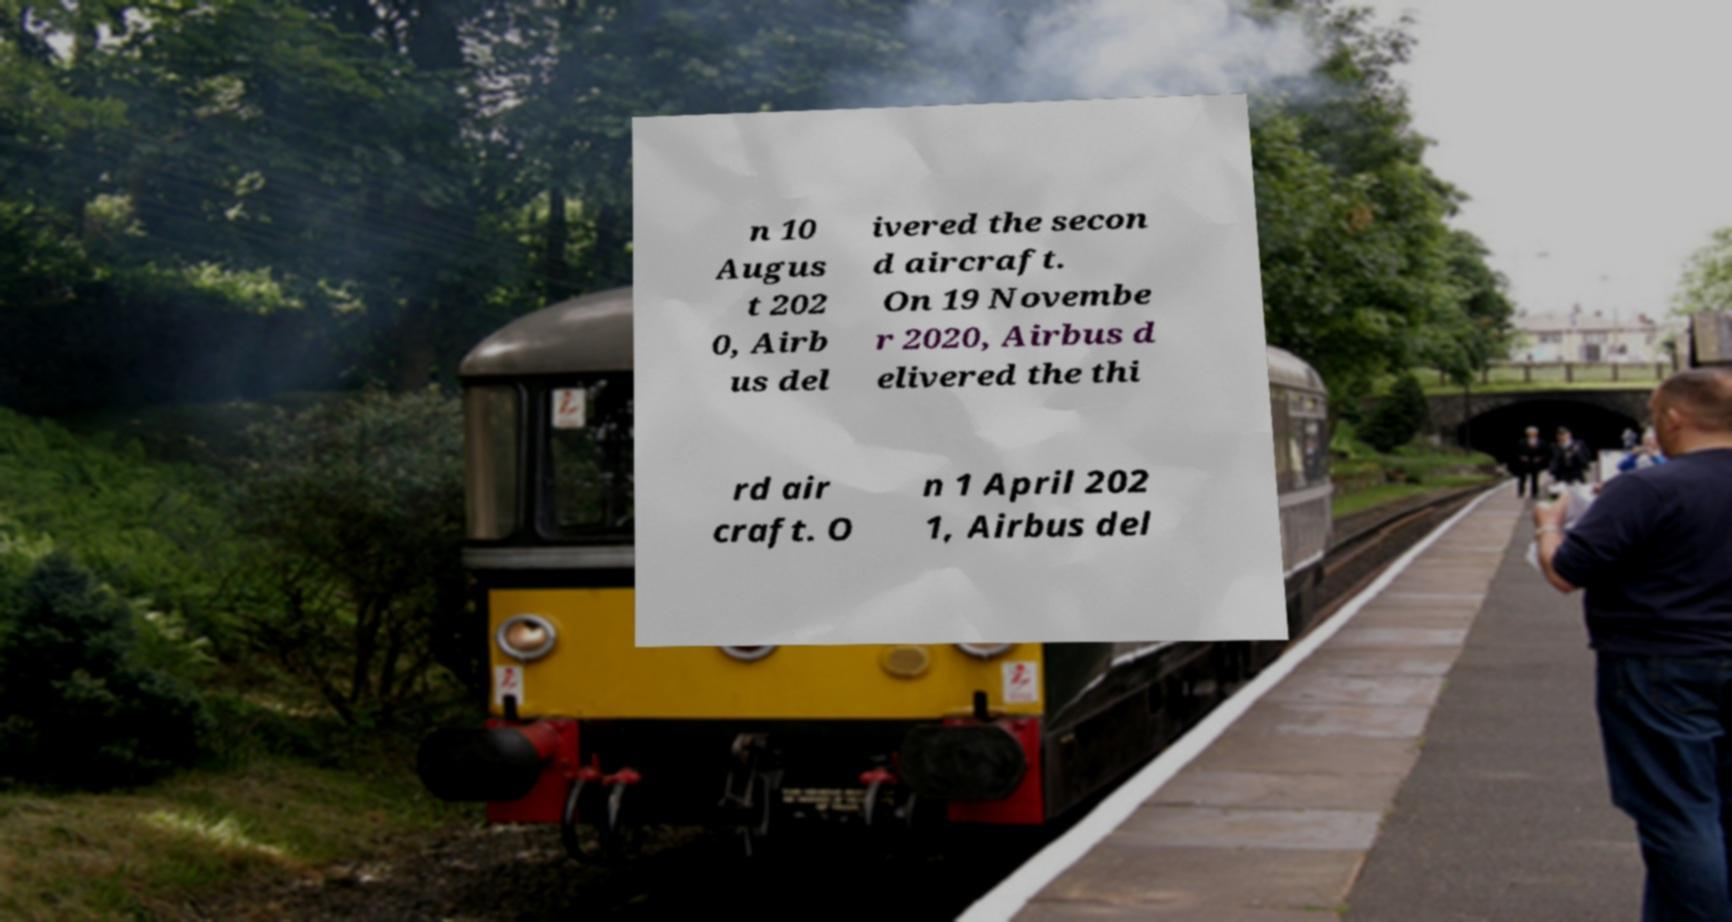Please identify and transcribe the text found in this image. n 10 Augus t 202 0, Airb us del ivered the secon d aircraft. On 19 Novembe r 2020, Airbus d elivered the thi rd air craft. O n 1 April 202 1, Airbus del 